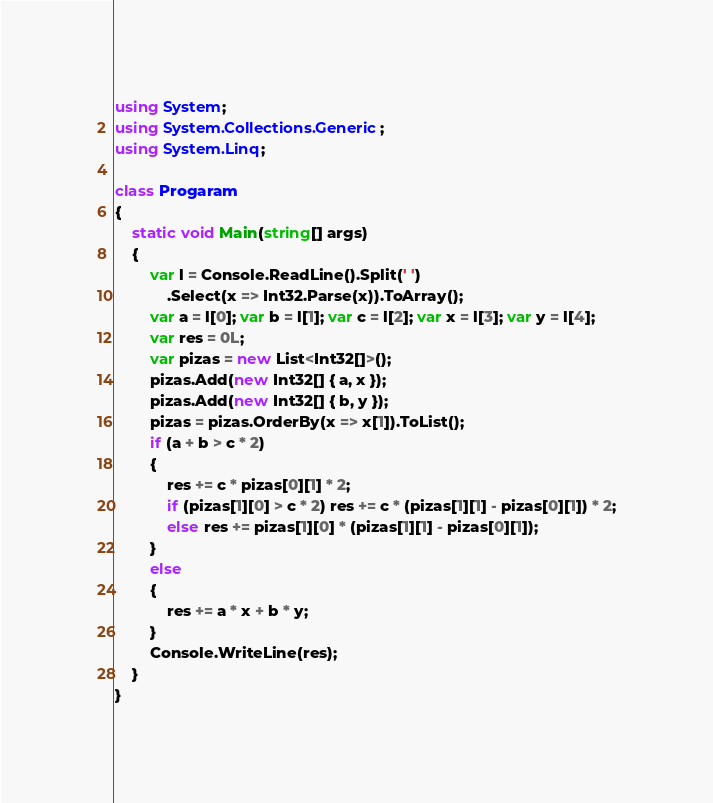Convert code to text. <code><loc_0><loc_0><loc_500><loc_500><_C#_>using System;
using System.Collections.Generic;
using System.Linq;

class Progaram
{
    static void Main(string[] args)
    {
        var l = Console.ReadLine().Split(' ')
            .Select(x => Int32.Parse(x)).ToArray();
        var a = l[0]; var b = l[1]; var c = l[2]; var x = l[3]; var y = l[4];
        var res = 0L;
        var pizas = new List<Int32[]>();
        pizas.Add(new Int32[] { a, x });
        pizas.Add(new Int32[] { b, y });
        pizas = pizas.OrderBy(x => x[1]).ToList();
        if (a + b > c * 2)
        {
            res += c * pizas[0][1] * 2;
            if (pizas[1][0] > c * 2) res += c * (pizas[1][1] - pizas[0][1]) * 2;
            else res += pizas[1][0] * (pizas[1][1] - pizas[0][1]);
        }
        else
        {
            res += a * x + b * y;
        }
        Console.WriteLine(res);
    }
}</code> 